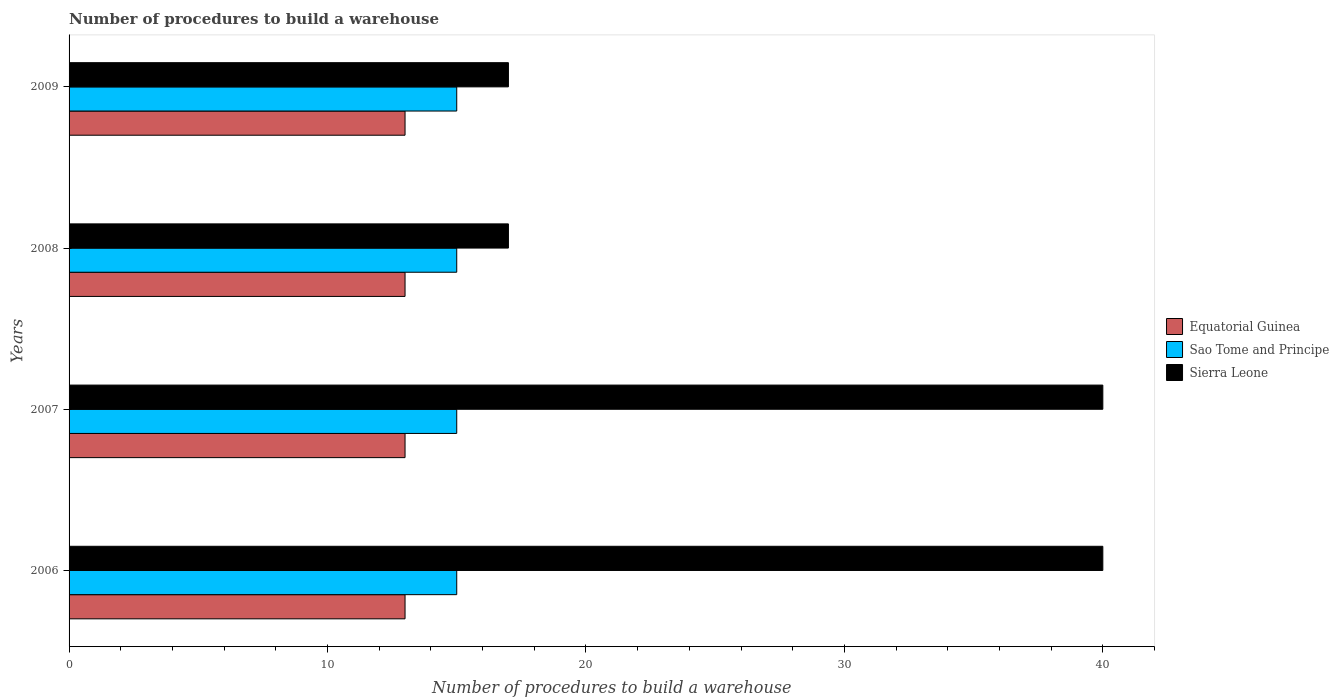How many different coloured bars are there?
Your answer should be very brief. 3. How many bars are there on the 2nd tick from the top?
Give a very brief answer. 3. How many bars are there on the 2nd tick from the bottom?
Provide a succinct answer. 3. What is the label of the 2nd group of bars from the top?
Give a very brief answer. 2008. What is the number of procedures to build a warehouse in in Sao Tome and Principe in 2007?
Your answer should be compact. 15. Across all years, what is the maximum number of procedures to build a warehouse in in Sao Tome and Principe?
Make the answer very short. 15. Across all years, what is the minimum number of procedures to build a warehouse in in Sao Tome and Principe?
Provide a short and direct response. 15. In which year was the number of procedures to build a warehouse in in Equatorial Guinea minimum?
Provide a succinct answer. 2006. What is the total number of procedures to build a warehouse in in Equatorial Guinea in the graph?
Make the answer very short. 52. What is the difference between the number of procedures to build a warehouse in in Equatorial Guinea in 2006 and the number of procedures to build a warehouse in in Sao Tome and Principe in 2008?
Provide a succinct answer. -2. In the year 2009, what is the difference between the number of procedures to build a warehouse in in Sao Tome and Principe and number of procedures to build a warehouse in in Sierra Leone?
Your answer should be very brief. -2. In how many years, is the number of procedures to build a warehouse in in Equatorial Guinea greater than 12 ?
Your response must be concise. 4. What is the ratio of the number of procedures to build a warehouse in in Sierra Leone in 2007 to that in 2009?
Your response must be concise. 2.35. Is the number of procedures to build a warehouse in in Sierra Leone in 2007 less than that in 2009?
Your answer should be compact. No. Is the difference between the number of procedures to build a warehouse in in Sao Tome and Principe in 2007 and 2009 greater than the difference between the number of procedures to build a warehouse in in Sierra Leone in 2007 and 2009?
Ensure brevity in your answer.  No. What is the difference between the highest and the second highest number of procedures to build a warehouse in in Sierra Leone?
Offer a terse response. 0. What does the 2nd bar from the top in 2007 represents?
Offer a very short reply. Sao Tome and Principe. What does the 3rd bar from the bottom in 2007 represents?
Give a very brief answer. Sierra Leone. Is it the case that in every year, the sum of the number of procedures to build a warehouse in in Equatorial Guinea and number of procedures to build a warehouse in in Sao Tome and Principe is greater than the number of procedures to build a warehouse in in Sierra Leone?
Give a very brief answer. No. How many years are there in the graph?
Give a very brief answer. 4. Does the graph contain any zero values?
Keep it short and to the point. No. Where does the legend appear in the graph?
Ensure brevity in your answer.  Center right. How many legend labels are there?
Make the answer very short. 3. What is the title of the graph?
Make the answer very short. Number of procedures to build a warehouse. Does "Samoa" appear as one of the legend labels in the graph?
Ensure brevity in your answer.  No. What is the label or title of the X-axis?
Offer a very short reply. Number of procedures to build a warehouse. What is the label or title of the Y-axis?
Your answer should be very brief. Years. What is the Number of procedures to build a warehouse in Sierra Leone in 2006?
Your answer should be compact. 40. What is the Number of procedures to build a warehouse of Equatorial Guinea in 2007?
Your answer should be compact. 13. What is the Number of procedures to build a warehouse in Sao Tome and Principe in 2008?
Your response must be concise. 15. What is the Number of procedures to build a warehouse in Sierra Leone in 2008?
Give a very brief answer. 17. What is the Number of procedures to build a warehouse in Equatorial Guinea in 2009?
Provide a short and direct response. 13. What is the Number of procedures to build a warehouse of Sao Tome and Principe in 2009?
Give a very brief answer. 15. Across all years, what is the maximum Number of procedures to build a warehouse in Sierra Leone?
Ensure brevity in your answer.  40. Across all years, what is the minimum Number of procedures to build a warehouse of Equatorial Guinea?
Your answer should be very brief. 13. Across all years, what is the minimum Number of procedures to build a warehouse in Sierra Leone?
Offer a very short reply. 17. What is the total Number of procedures to build a warehouse in Equatorial Guinea in the graph?
Provide a short and direct response. 52. What is the total Number of procedures to build a warehouse in Sao Tome and Principe in the graph?
Give a very brief answer. 60. What is the total Number of procedures to build a warehouse of Sierra Leone in the graph?
Your answer should be very brief. 114. What is the difference between the Number of procedures to build a warehouse in Equatorial Guinea in 2006 and that in 2007?
Ensure brevity in your answer.  0. What is the difference between the Number of procedures to build a warehouse of Sao Tome and Principe in 2006 and that in 2007?
Ensure brevity in your answer.  0. What is the difference between the Number of procedures to build a warehouse of Sierra Leone in 2006 and that in 2008?
Offer a very short reply. 23. What is the difference between the Number of procedures to build a warehouse in Sierra Leone in 2006 and that in 2009?
Keep it short and to the point. 23. What is the difference between the Number of procedures to build a warehouse of Equatorial Guinea in 2007 and that in 2008?
Offer a very short reply. 0. What is the difference between the Number of procedures to build a warehouse in Sao Tome and Principe in 2007 and that in 2009?
Provide a succinct answer. 0. What is the difference between the Number of procedures to build a warehouse in Sao Tome and Principe in 2008 and that in 2009?
Keep it short and to the point. 0. What is the difference between the Number of procedures to build a warehouse in Sierra Leone in 2008 and that in 2009?
Offer a very short reply. 0. What is the difference between the Number of procedures to build a warehouse in Equatorial Guinea in 2006 and the Number of procedures to build a warehouse in Sao Tome and Principe in 2007?
Your answer should be very brief. -2. What is the difference between the Number of procedures to build a warehouse of Equatorial Guinea in 2006 and the Number of procedures to build a warehouse of Sao Tome and Principe in 2008?
Offer a terse response. -2. What is the difference between the Number of procedures to build a warehouse of Sao Tome and Principe in 2006 and the Number of procedures to build a warehouse of Sierra Leone in 2008?
Your answer should be very brief. -2. What is the difference between the Number of procedures to build a warehouse in Sao Tome and Principe in 2006 and the Number of procedures to build a warehouse in Sierra Leone in 2009?
Provide a succinct answer. -2. What is the difference between the Number of procedures to build a warehouse of Equatorial Guinea in 2007 and the Number of procedures to build a warehouse of Sierra Leone in 2008?
Offer a very short reply. -4. What is the difference between the Number of procedures to build a warehouse of Equatorial Guinea in 2007 and the Number of procedures to build a warehouse of Sao Tome and Principe in 2009?
Keep it short and to the point. -2. What is the difference between the Number of procedures to build a warehouse of Sao Tome and Principe in 2007 and the Number of procedures to build a warehouse of Sierra Leone in 2009?
Offer a very short reply. -2. What is the difference between the Number of procedures to build a warehouse in Equatorial Guinea in 2008 and the Number of procedures to build a warehouse in Sao Tome and Principe in 2009?
Make the answer very short. -2. What is the difference between the Number of procedures to build a warehouse of Sao Tome and Principe in 2008 and the Number of procedures to build a warehouse of Sierra Leone in 2009?
Give a very brief answer. -2. What is the average Number of procedures to build a warehouse of Sao Tome and Principe per year?
Offer a very short reply. 15. In the year 2006, what is the difference between the Number of procedures to build a warehouse in Equatorial Guinea and Number of procedures to build a warehouse in Sao Tome and Principe?
Provide a short and direct response. -2. In the year 2006, what is the difference between the Number of procedures to build a warehouse in Equatorial Guinea and Number of procedures to build a warehouse in Sierra Leone?
Your response must be concise. -27. In the year 2006, what is the difference between the Number of procedures to build a warehouse of Sao Tome and Principe and Number of procedures to build a warehouse of Sierra Leone?
Offer a very short reply. -25. In the year 2007, what is the difference between the Number of procedures to build a warehouse in Equatorial Guinea and Number of procedures to build a warehouse in Sao Tome and Principe?
Keep it short and to the point. -2. In the year 2007, what is the difference between the Number of procedures to build a warehouse of Sao Tome and Principe and Number of procedures to build a warehouse of Sierra Leone?
Your answer should be very brief. -25. In the year 2008, what is the difference between the Number of procedures to build a warehouse in Equatorial Guinea and Number of procedures to build a warehouse in Sao Tome and Principe?
Provide a short and direct response. -2. In the year 2008, what is the difference between the Number of procedures to build a warehouse in Equatorial Guinea and Number of procedures to build a warehouse in Sierra Leone?
Your answer should be compact. -4. In the year 2009, what is the difference between the Number of procedures to build a warehouse of Equatorial Guinea and Number of procedures to build a warehouse of Sao Tome and Principe?
Offer a terse response. -2. What is the ratio of the Number of procedures to build a warehouse of Equatorial Guinea in 2006 to that in 2007?
Offer a terse response. 1. What is the ratio of the Number of procedures to build a warehouse in Sierra Leone in 2006 to that in 2007?
Provide a succinct answer. 1. What is the ratio of the Number of procedures to build a warehouse of Sierra Leone in 2006 to that in 2008?
Offer a very short reply. 2.35. What is the ratio of the Number of procedures to build a warehouse of Sao Tome and Principe in 2006 to that in 2009?
Provide a short and direct response. 1. What is the ratio of the Number of procedures to build a warehouse in Sierra Leone in 2006 to that in 2009?
Ensure brevity in your answer.  2.35. What is the ratio of the Number of procedures to build a warehouse of Equatorial Guinea in 2007 to that in 2008?
Your answer should be compact. 1. What is the ratio of the Number of procedures to build a warehouse of Sierra Leone in 2007 to that in 2008?
Keep it short and to the point. 2.35. What is the ratio of the Number of procedures to build a warehouse of Equatorial Guinea in 2007 to that in 2009?
Your answer should be compact. 1. What is the ratio of the Number of procedures to build a warehouse of Sierra Leone in 2007 to that in 2009?
Provide a succinct answer. 2.35. What is the ratio of the Number of procedures to build a warehouse of Equatorial Guinea in 2008 to that in 2009?
Offer a very short reply. 1. What is the difference between the highest and the second highest Number of procedures to build a warehouse of Sao Tome and Principe?
Make the answer very short. 0. What is the difference between the highest and the second highest Number of procedures to build a warehouse of Sierra Leone?
Offer a very short reply. 0. What is the difference between the highest and the lowest Number of procedures to build a warehouse of Equatorial Guinea?
Ensure brevity in your answer.  0. What is the difference between the highest and the lowest Number of procedures to build a warehouse of Sao Tome and Principe?
Provide a short and direct response. 0. 